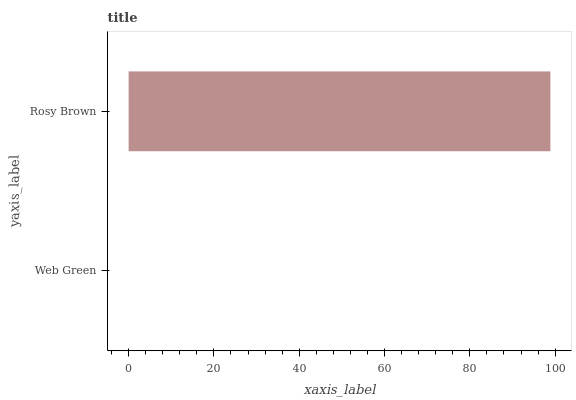Is Web Green the minimum?
Answer yes or no. Yes. Is Rosy Brown the maximum?
Answer yes or no. Yes. Is Rosy Brown the minimum?
Answer yes or no. No. Is Rosy Brown greater than Web Green?
Answer yes or no. Yes. Is Web Green less than Rosy Brown?
Answer yes or no. Yes. Is Web Green greater than Rosy Brown?
Answer yes or no. No. Is Rosy Brown less than Web Green?
Answer yes or no. No. Is Rosy Brown the high median?
Answer yes or no. Yes. Is Web Green the low median?
Answer yes or no. Yes. Is Web Green the high median?
Answer yes or no. No. Is Rosy Brown the low median?
Answer yes or no. No. 